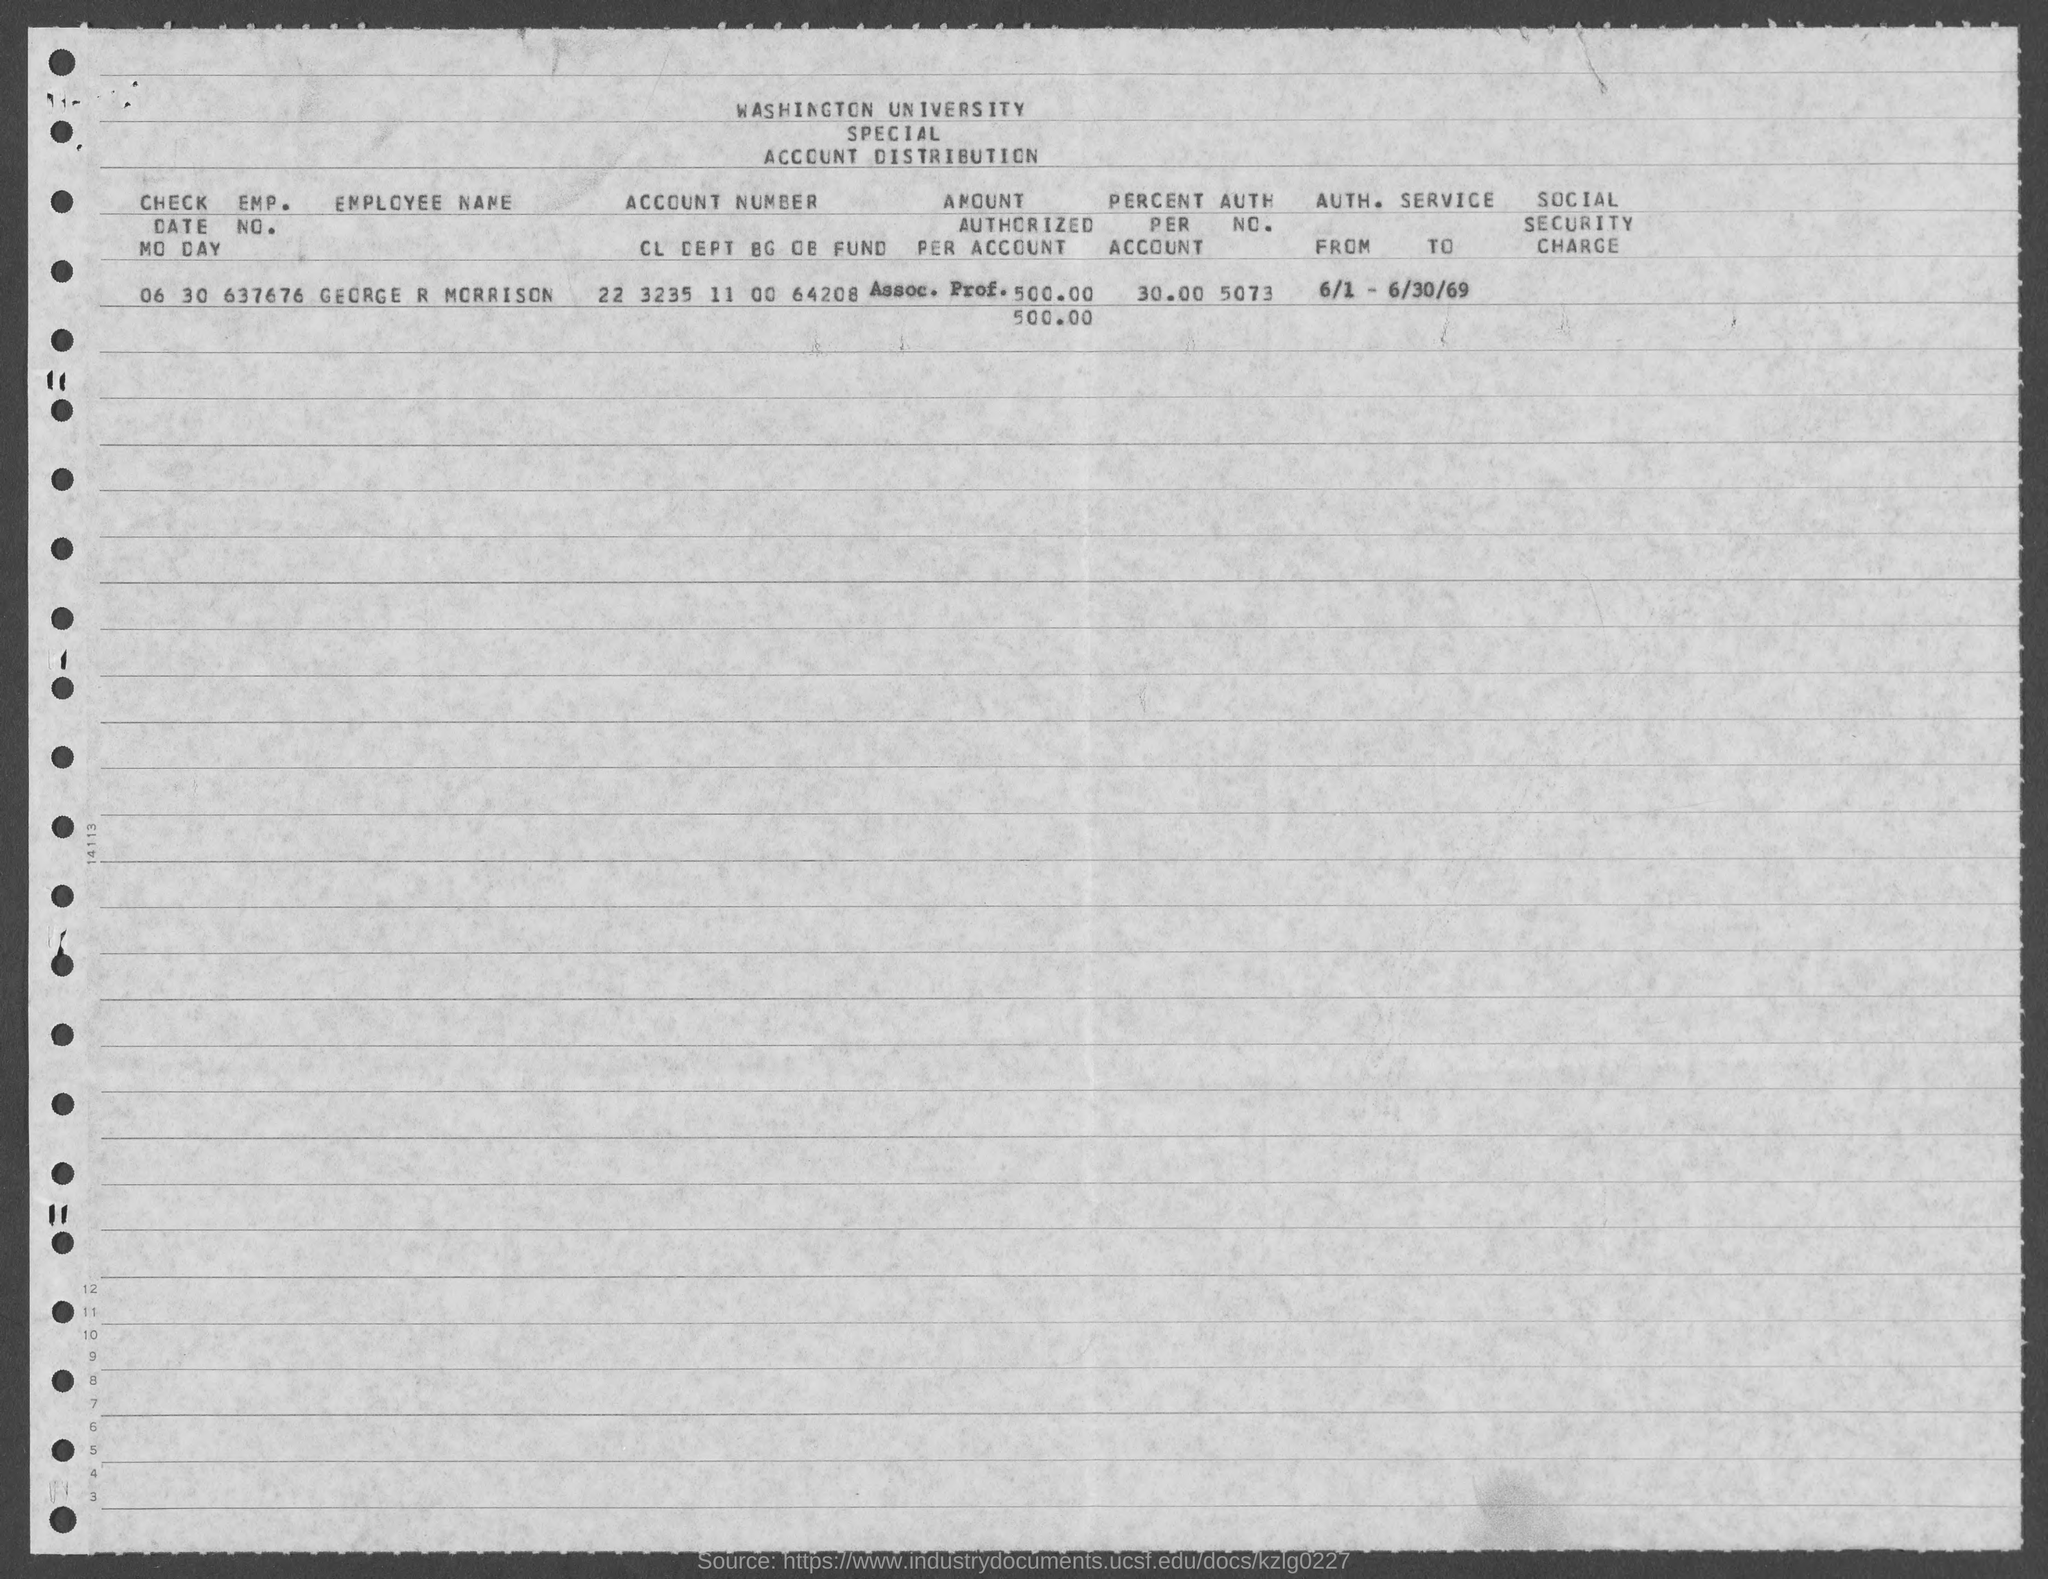Which university's account distirbution is given here?
Give a very brief answer. WASHINGTON. What is the employee name given in the document?
Ensure brevity in your answer.  GEORGE R MORRISON. What is the EMP. NO. of GEORGE R MORRISON?
Offer a very short reply. 637676. What is the percent per account of GEORGE R MORRISON?
Your answer should be compact. 30.00. What is the AUTH. NO. of GEORGE R MORRISON given in the document?
Your answer should be very brief. 5073. 